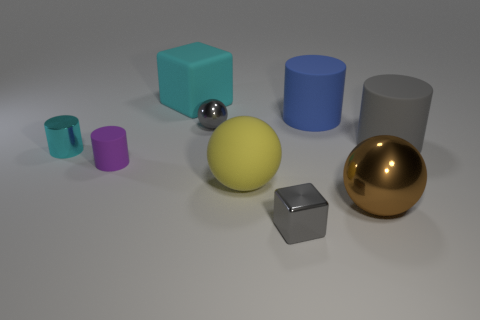There is a metallic thing that is the same color as the small cube; what is its size?
Provide a succinct answer. Small. There is a blue thing; are there any big things behind it?
Offer a very short reply. Yes. Is the number of tiny cyan metallic objects that are behind the brown metal thing greater than the number of large purple objects?
Your answer should be compact. Yes. Are there any rubber objects that have the same color as the metal block?
Your answer should be very brief. Yes. What is the color of the block that is the same size as the purple matte thing?
Provide a succinct answer. Gray. There is a ball that is behind the yellow matte sphere; are there any large yellow objects behind it?
Your response must be concise. No. There is a big cylinder that is left of the large gray matte cylinder; what is it made of?
Your answer should be very brief. Rubber. Do the large ball to the right of the tiny gray block and the tiny thing that is in front of the brown thing have the same material?
Your response must be concise. Yes. Is the number of cylinders that are in front of the cyan shiny cylinder the same as the number of gray shiny objects to the right of the large metal sphere?
Your answer should be very brief. No. What number of big yellow things are made of the same material as the yellow sphere?
Offer a very short reply. 0. 